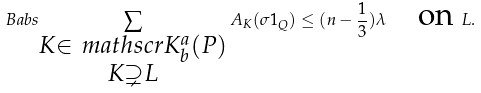Convert formula to latex. <formula><loc_0><loc_0><loc_500><loc_500>\ B a b s { \sum _ { \substack { K \in \ m a t h s c r { K } ^ { a } _ { b } ( P ) \\ K \supsetneq L } } A _ { K } ( \sigma 1 _ { Q } ) } \leq ( n - \frac { 1 } { 3 } ) \lambda \quad \text {on } L .</formula> 